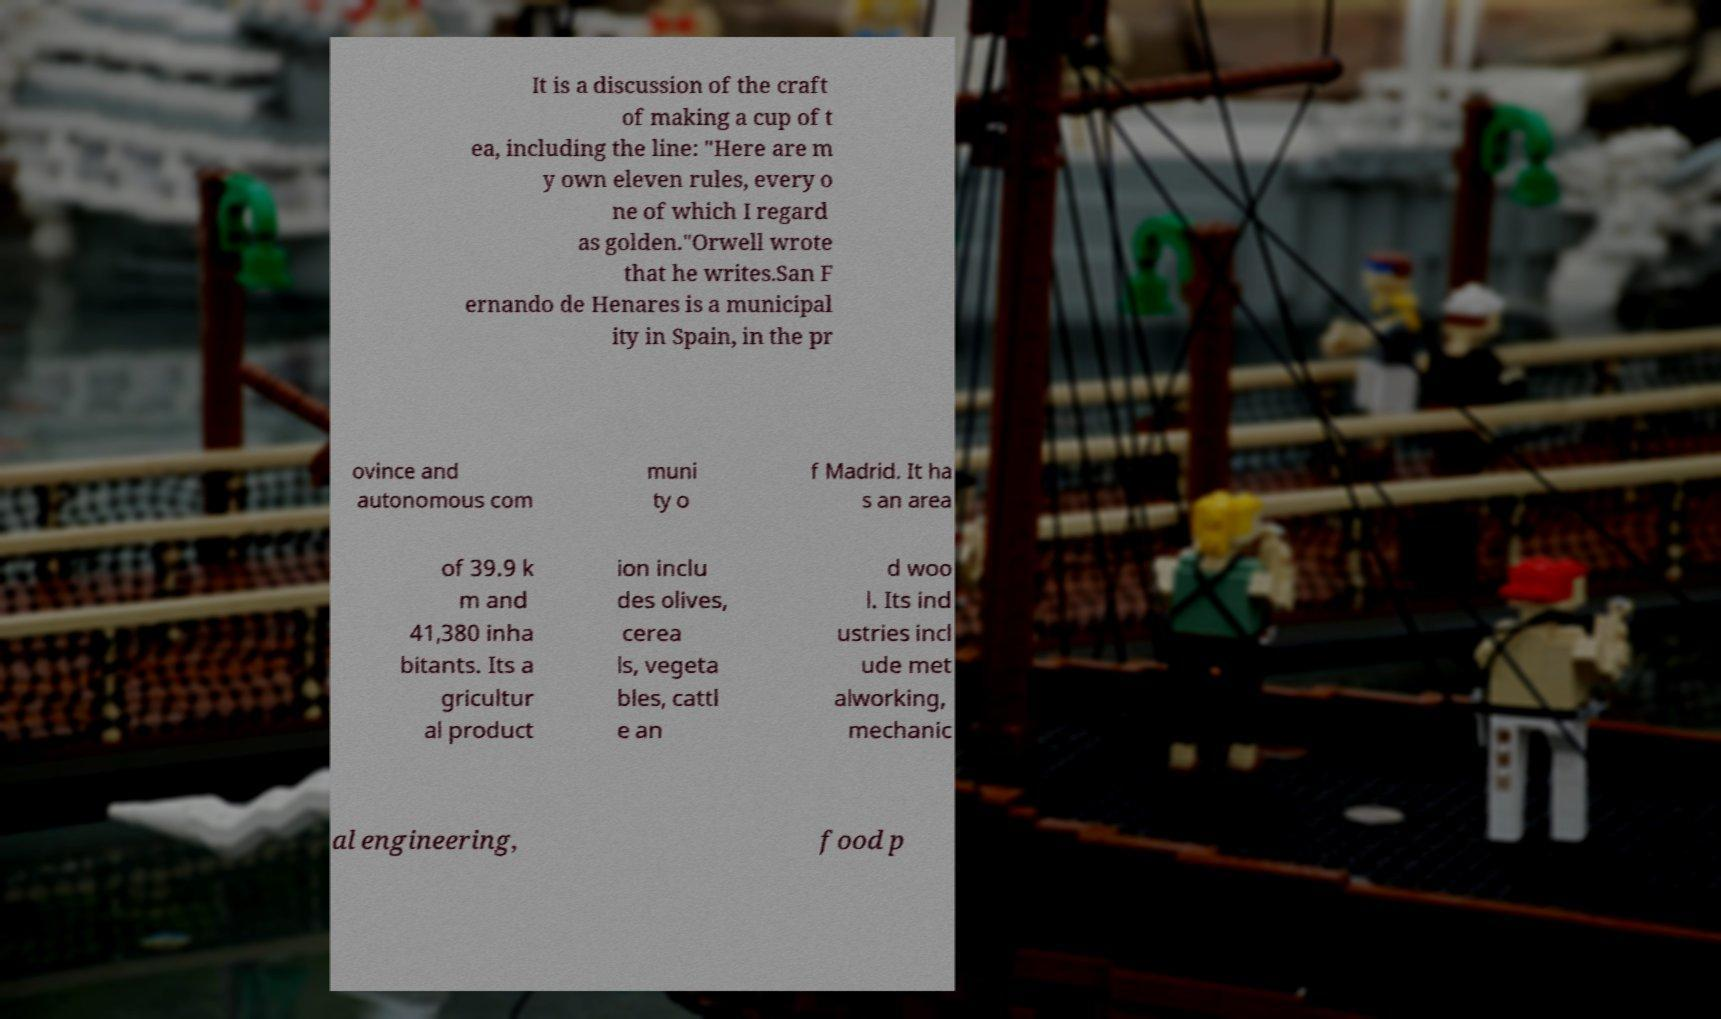Can you read and provide the text displayed in the image?This photo seems to have some interesting text. Can you extract and type it out for me? It is a discussion of the craft of making a cup of t ea, including the line: "Here are m y own eleven rules, every o ne of which I regard as golden."Orwell wrote that he writes.San F ernando de Henares is a municipal ity in Spain, in the pr ovince and autonomous com muni ty o f Madrid. It ha s an area of 39.9 k m and 41,380 inha bitants. Its a gricultur al product ion inclu des olives, cerea ls, vegeta bles, cattl e an d woo l. Its ind ustries incl ude met alworking, mechanic al engineering, food p 